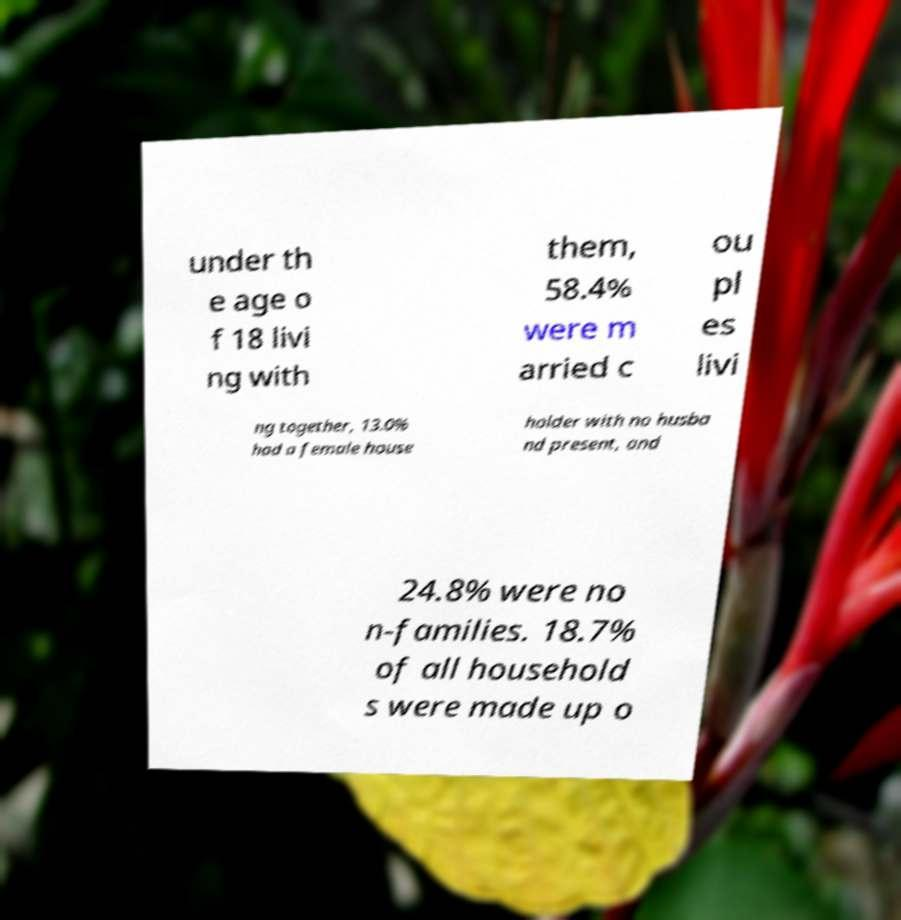For documentation purposes, I need the text within this image transcribed. Could you provide that? under th e age o f 18 livi ng with them, 58.4% were m arried c ou pl es livi ng together, 13.0% had a female house holder with no husba nd present, and 24.8% were no n-families. 18.7% of all household s were made up o 